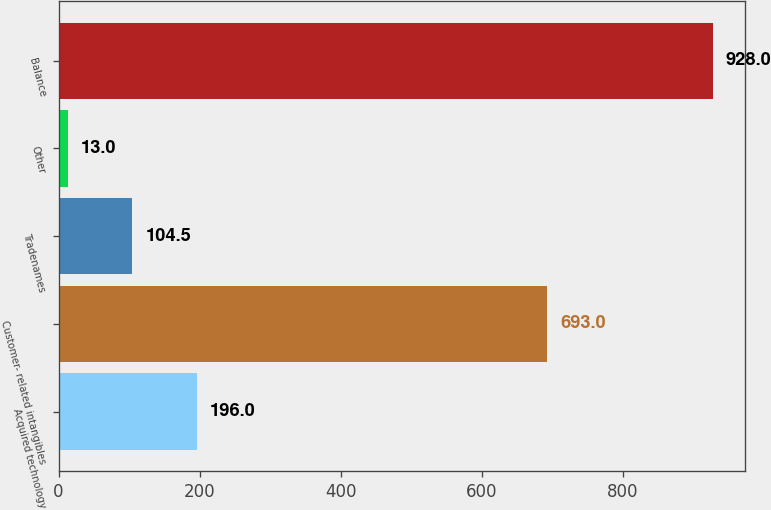Convert chart. <chart><loc_0><loc_0><loc_500><loc_500><bar_chart><fcel>Acquired technology<fcel>Customer- related intangibles<fcel>Tradenames<fcel>Other<fcel>Balance<nl><fcel>196<fcel>693<fcel>104.5<fcel>13<fcel>928<nl></chart> 